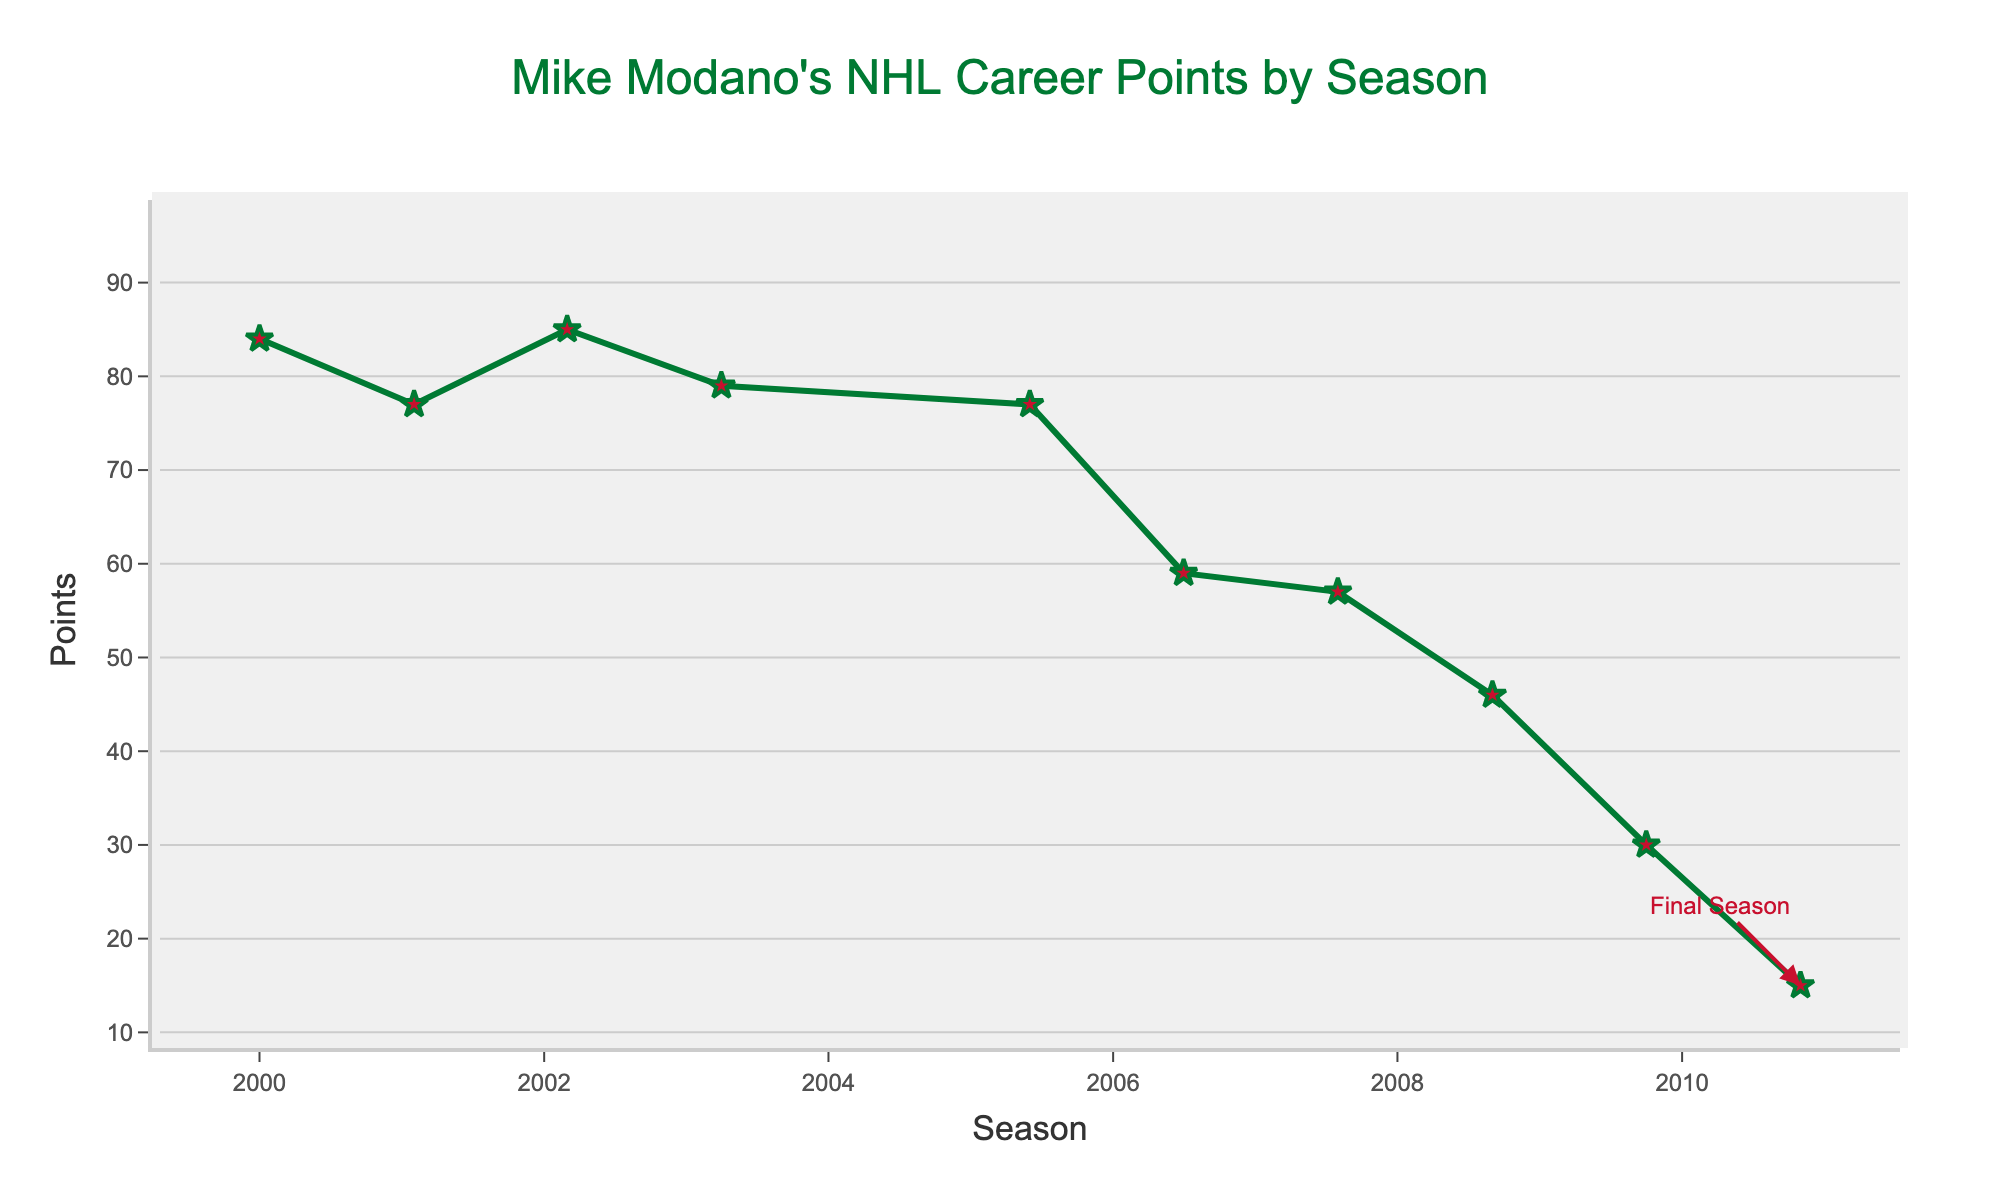Which season did Mike Modano have his highest points? Observing the plot, the peak points during Mike Modano's career are seen in the seasons 1992-93 and 1993-94 with the highest value reached. Therefore, the seasons with highest points are 1992-93 and 1993-94 each with 93 points
Answer: 1992-93 and 1993-94 What is the difference in points between Mike Modano's first season and his second-best season? From the plot, Mike Modano's first season (1989-90) had 29 points. His second-best season was 2002-03 with 85 points. The difference can be calculated as 85 - 29 = 56
Answer: 56 During which seasons did Mike Modano’s points fall below 50? By viewing the plot, the seasons where Mike Modano’s points fell below 50 are: 1989-90, 2008-09, 2009-10, and 2010-11.
Answer: 1989-90, 2008-09, 2009-10, 2010-11 Across his entire career, what was the average number of points per season for Mike Modano? To find the average number of points per season, sum up all the points (1247) and divide by the number of seasons (21): 1247 / 21 ≈ 59.4
Answer: 59.4 Which seasons had points greater than 80 but less than 90? From the plot, the seasons where points were greater than 80 but less than 90 are 2000-01 and 2002-03.
Answer: 2000-01, 2002-03 Describe the trend in Mike Modano's performance in his final three seasons. By observing the plot, it can be seen that in the final three seasons (2008-09, 2009-10, and 2010-11), Mike Modano's points decreased gradually from 46, to 30, and finally to 15.
Answer: Decreasing trend Identify any two seasons where there was an equal number of points scored by Mike Modano. From the plot, two seasons where there was an equal number of points scored are 1993-94 and 1992-93 (93 points each)
Answer: 1992-93 and 1993-94 